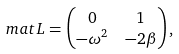<formula> <loc_0><loc_0><loc_500><loc_500>\ m a t { L } & = \begin{pmatrix} 0 & 1 \\ - \omega ^ { 2 } & - 2 \beta \end{pmatrix} ,</formula> 